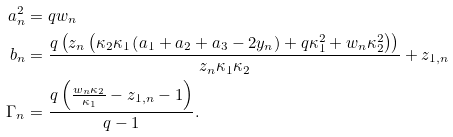Convert formula to latex. <formula><loc_0><loc_0><loc_500><loc_500>a _ { n } ^ { 2 } & = q w _ { n } \\ b _ { n } & = \frac { q \left ( z _ { n } \left ( \kappa _ { 2 } \kappa _ { 1 } \left ( a _ { 1 } + a _ { 2 } + a _ { 3 } - 2 y _ { n } \right ) + q \kappa _ { 1 } ^ { 2 } + w _ { n } \kappa _ { 2 } ^ { 2 } \right ) \right ) } { z _ { n } \kappa _ { 1 } \kappa _ { 2 } } + z _ { 1 , n } \\ \Gamma _ { n } & = \frac { q \left ( \frac { w _ { n } \kappa _ { 2 } } { \kappa _ { 1 } } - z _ { 1 , n } - 1 \right ) } { q - 1 } .</formula> 